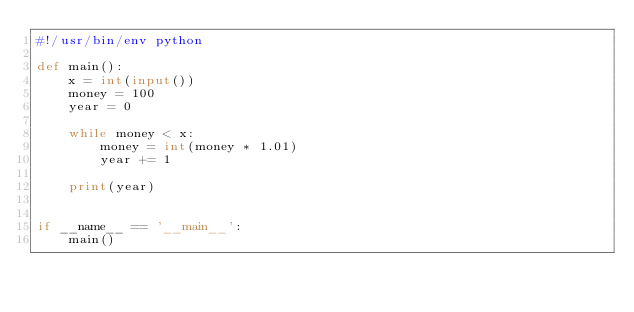Convert code to text. <code><loc_0><loc_0><loc_500><loc_500><_Python_>#!/usr/bin/env python

def main():
    x = int(input())
    money = 100
    year = 0

    while money < x:
        money = int(money * 1.01)
        year += 1

    print(year)


if __name__ == '__main__':
    main()
</code> 